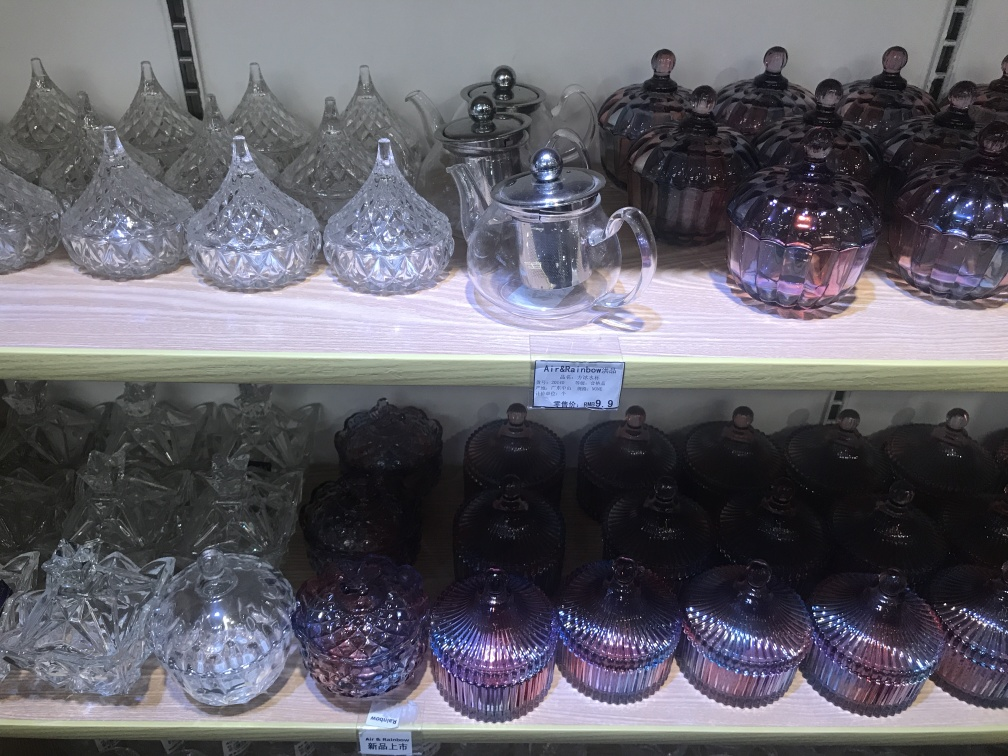Does the teapot retain most of the texture details? Yes, the teapot retains most of the texture details visible in the image. The intricate patterns and the reflective quality of the material are clearly discernible, showcasing the craftsmanship involved in its design. 